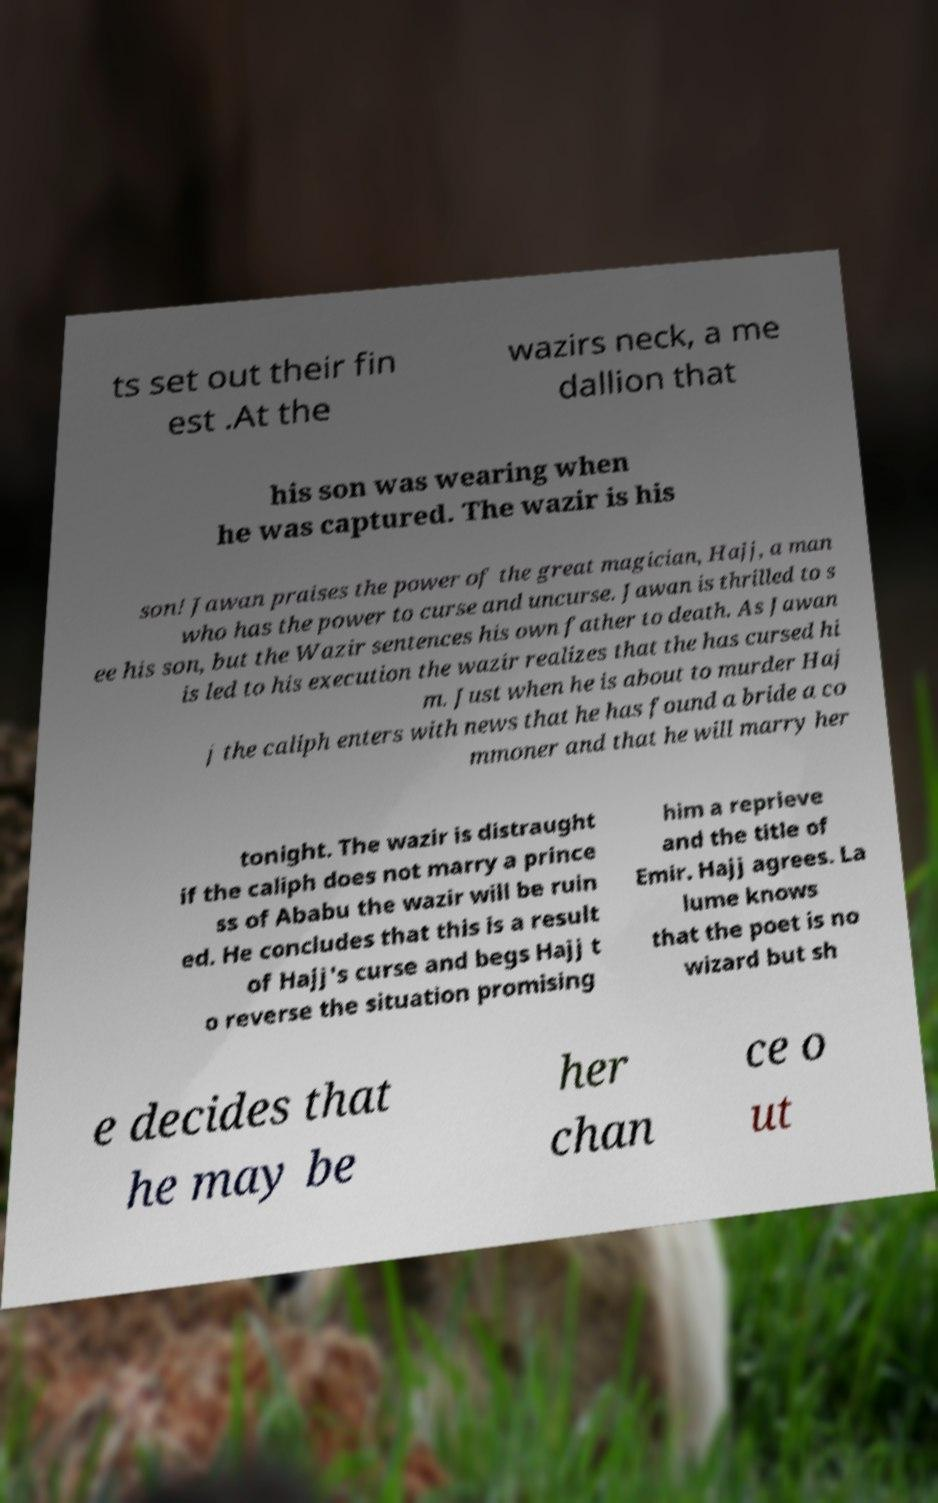For documentation purposes, I need the text within this image transcribed. Could you provide that? ts set out their fin est .At the wazirs neck, a me dallion that his son was wearing when he was captured. The wazir is his son! Jawan praises the power of the great magician, Hajj, a man who has the power to curse and uncurse. Jawan is thrilled to s ee his son, but the Wazir sentences his own father to death. As Jawan is led to his execution the wazir realizes that the has cursed hi m. Just when he is about to murder Haj j the caliph enters with news that he has found a bride a co mmoner and that he will marry her tonight. The wazir is distraught if the caliph does not marry a prince ss of Ababu the wazir will be ruin ed. He concludes that this is a result of Hajj's curse and begs Hajj t o reverse the situation promising him a reprieve and the title of Emir. Hajj agrees. La lume knows that the poet is no wizard but sh e decides that he may be her chan ce o ut 